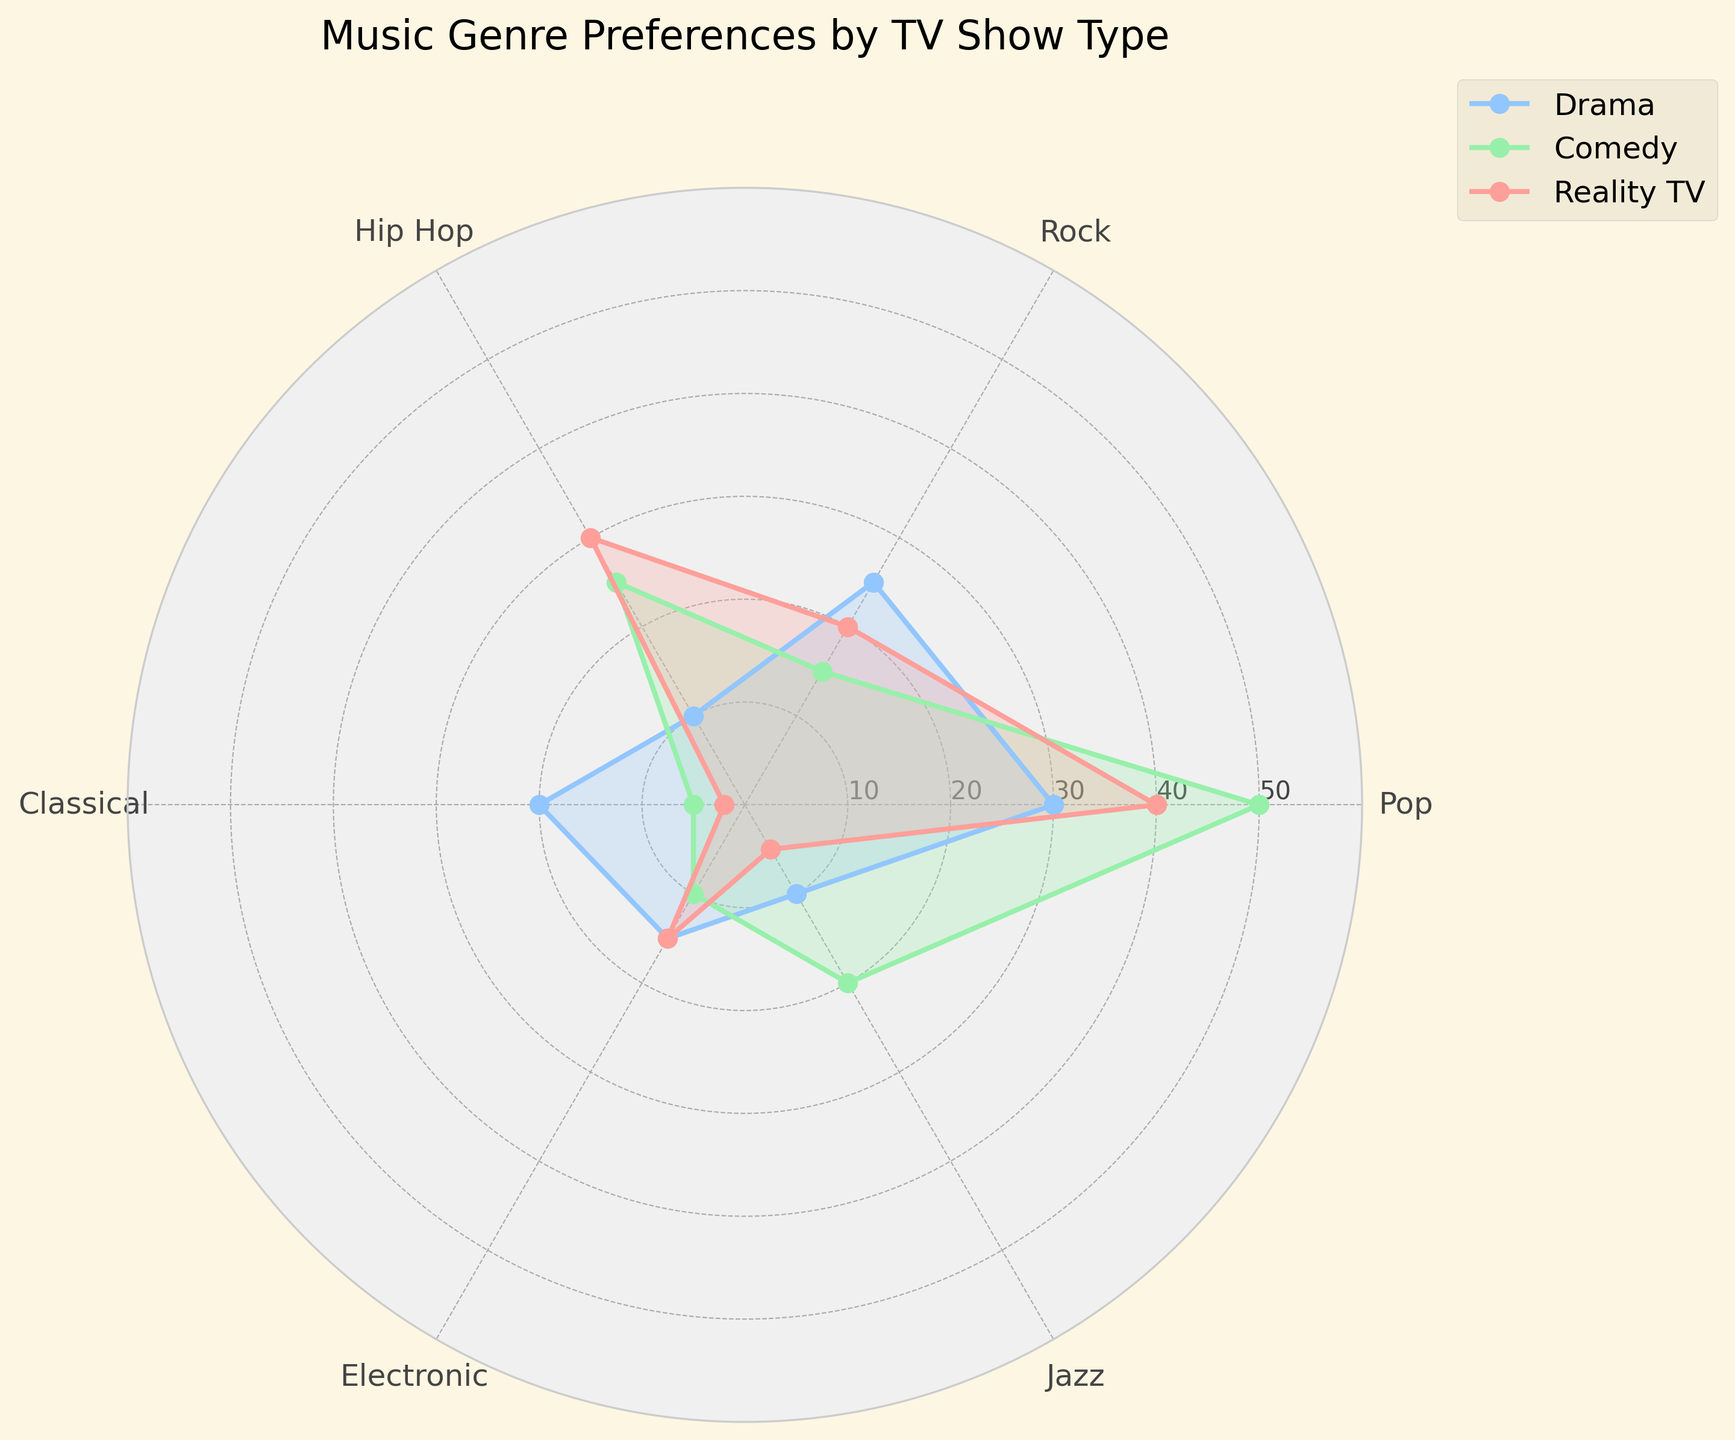How many genres are displayed in the radar chart? By looking at the radar chart, we count the number of unique genres around the perimeter of the chart. These are Pop, Rock, Hip Hop, Classical, Electronic, and Jazz.
Answer: 6 Which TV show type prefers Hip Hop the most? Examine the Hip Hop values for each TV show type. Drama is at 10, Comedy is at 25, and Reality TV is at 30. Reality TV has the highest value.
Answer: Reality TV What is the range of values for the Electronic genre across the three TV show types? Determine the minimum and maximum values of the Electronic genre; here, both Drama and Reality TV are at 15, and Comedy is at 10. The range is calculated by subtracting the minimum from the maximum: 15 - 10.
Answer: 5 Which genre has the lowest preference in Drama? Find the lowest value among Drama's genre values; Pop is 30, Rock is 25, Hip Hop is 10, Classical is 20, Electronic is 15, and Jazz is 10. So, Hip Hop and Jazz both have the lowest values.
Answer: Hip Hop, Jazz In which genre(s) do both Drama and Reality TV have equal values? Compare the genre values for Drama and Reality TV. Only the Electronic genre is equal, with both at 15.
Answer: Electronic What is the average preference value for the Pop genre across all TV show types? Add the Pop values for each TV show type: Drama (30), Comedy (50), Reality TV (40). The total is 120. Then, divide by the number of categories (3): 120 / 3.
Answer: 40 Which TV show type shows the least variation in genre preference? Calculate the range (difference between maximum and minimum values) for each TV show type and compare. For Drama: 30 - 10 = 20, Comedy: 50 - 5 = 45, Reality TV: 40 - 2 = 38. Drama has the smallest range.
Answer: Drama How much more preferred is Pop in Comedy compared to Pop in Drama? Subtract the Drama value of Pop from the Comedy value of Pop: 50 - 30.
Answer: 20 What is the most preferred genre for Comedy? Identify the genre with the highest value for Comedy. The values are Pop (50), Rock (15), Hip Hop (25), Classical (5), Electronic (10), Jazz (20). Pop is the highest.
Answer: Pop Which TV show type has the highest preference for Classical music? Compare the Classical values for each TV show type: Drama is 20, Comedy is 5, and Reality TV is 2. Drama has the highest value.
Answer: Drama 